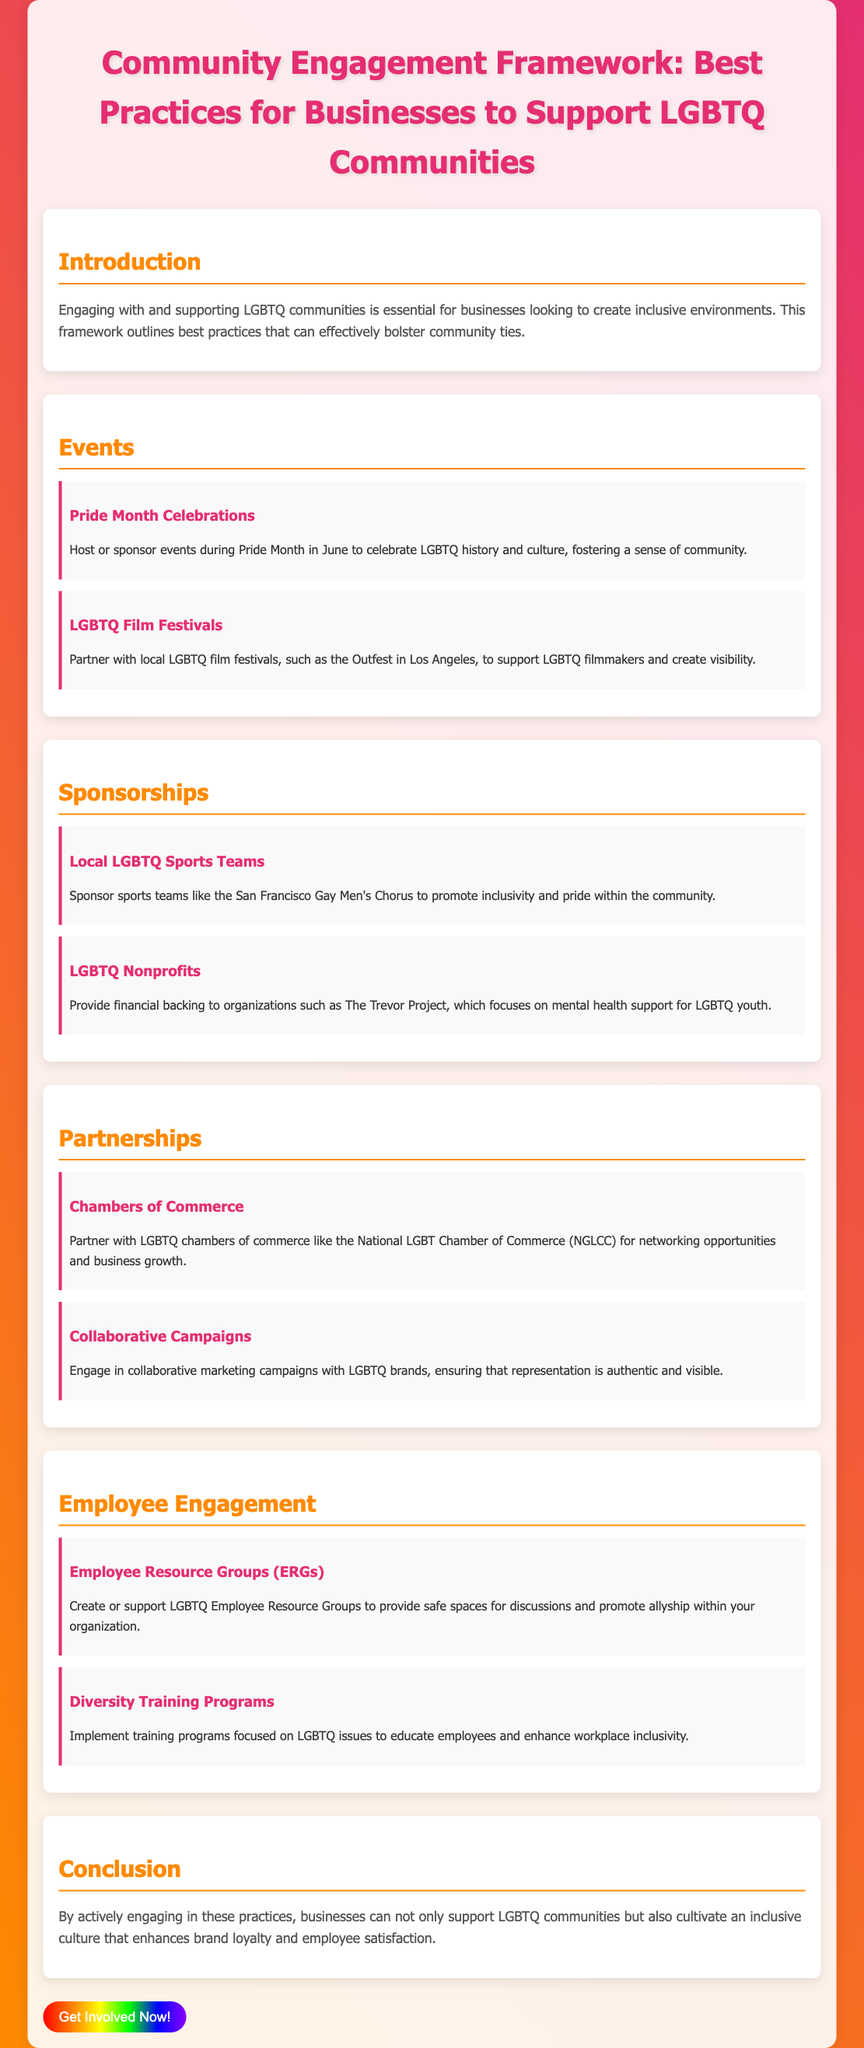What month is recognized for Pride celebrations in the document? The document explicitly states that Pride Month is celebrated in June.
Answer: June What organization focuses on mental health support for LGBTQ youth? The document mentions The Trevor Project as an organization focused on mental health support for LGBTQ youth.
Answer: The Trevor Project What kind of events should businesses host during Pride Month? The document suggests hosting celebrations to celebrate LGBTQ history and culture during Pride Month.
Answer: Celebrations Which local LGBTQ film festival is mentioned? The document specifically references Outfest in Los Angeles as an LGBTQ film festival to partner with.
Answer: Outfest What resource groups should businesses create or support? According to the document, businesses should create or support LGBTQ Employee Resource Groups.
Answer: Employee Resource Groups What type of training programs are recommended for employees? The document recommends implementing diversity training programs focused on LGBTQ issues.
Answer: Diversity training programs What chambers of commerce should businesses partner with? The document mentions partnering with LGBTQ chambers of commerce like the National LGBT Chamber of Commerce.
Answer: National LGBT Chamber of Commerce How can businesses enhance brand loyalty and employee satisfaction? The document concludes that engaging in best practices can cultivate an inclusive culture, thereby enhancing brand loyalty and employee satisfaction.
Answer: Inclusive culture 